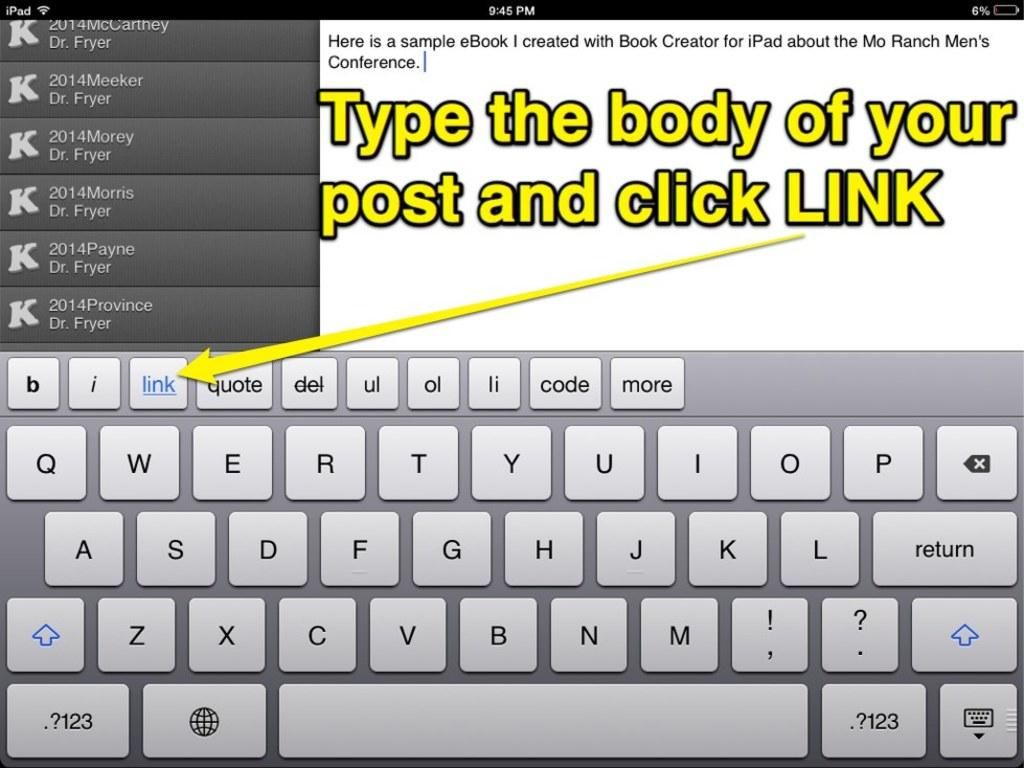<image>
Relay a brief, clear account of the picture shown. An instruction with a virtual keyboard on how to create an eBook with Book Creator for iPad. 